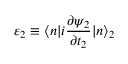<formula> <loc_0><loc_0><loc_500><loc_500>\varepsilon _ { 2 } \equiv \langle n | i \frac { \partial \psi _ { 2 } } { \partial t _ { 2 } } | n \rangle _ { 2 }</formula> 